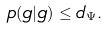Convert formula to latex. <formula><loc_0><loc_0><loc_500><loc_500>p ( g | g ) \leq d _ { \Psi } .</formula> 